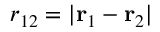Convert formula to latex. <formula><loc_0><loc_0><loc_500><loc_500>r _ { 1 2 } = | { r } _ { 1 } - { r } _ { 2 } |</formula> 